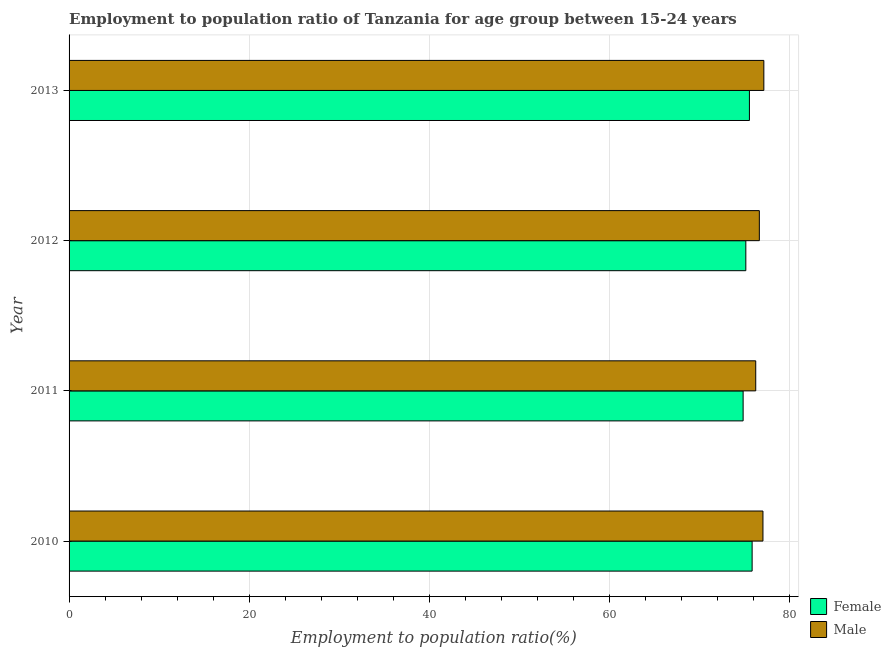Are the number of bars per tick equal to the number of legend labels?
Ensure brevity in your answer.  Yes. Are the number of bars on each tick of the Y-axis equal?
Provide a succinct answer. Yes. What is the label of the 3rd group of bars from the top?
Keep it short and to the point. 2011. In how many cases, is the number of bars for a given year not equal to the number of legend labels?
Provide a short and direct response. 0. What is the employment to population ratio(female) in 2012?
Offer a terse response. 75.1. Across all years, what is the maximum employment to population ratio(female)?
Ensure brevity in your answer.  75.8. Across all years, what is the minimum employment to population ratio(male)?
Your answer should be very brief. 76.2. In which year was the employment to population ratio(female) maximum?
Keep it short and to the point. 2010. In which year was the employment to population ratio(male) minimum?
Provide a succinct answer. 2011. What is the total employment to population ratio(male) in the graph?
Offer a terse response. 306.9. What is the difference between the employment to population ratio(female) in 2010 and the employment to population ratio(male) in 2013?
Your response must be concise. -1.3. What is the average employment to population ratio(male) per year?
Provide a succinct answer. 76.72. In how many years, is the employment to population ratio(female) greater than 76 %?
Give a very brief answer. 0. Is the difference between the employment to population ratio(female) in 2012 and 2013 greater than the difference between the employment to population ratio(male) in 2012 and 2013?
Your response must be concise. Yes. What is the difference between the highest and the second highest employment to population ratio(female)?
Offer a very short reply. 0.3. In how many years, is the employment to population ratio(female) greater than the average employment to population ratio(female) taken over all years?
Ensure brevity in your answer.  2. How many bars are there?
Your answer should be compact. 8. Are the values on the major ticks of X-axis written in scientific E-notation?
Provide a succinct answer. No. How are the legend labels stacked?
Offer a very short reply. Vertical. What is the title of the graph?
Give a very brief answer. Employment to population ratio of Tanzania for age group between 15-24 years. Does "Fixed telephone" appear as one of the legend labels in the graph?
Ensure brevity in your answer.  No. What is the label or title of the X-axis?
Ensure brevity in your answer.  Employment to population ratio(%). What is the label or title of the Y-axis?
Keep it short and to the point. Year. What is the Employment to population ratio(%) of Female in 2010?
Give a very brief answer. 75.8. What is the Employment to population ratio(%) of Female in 2011?
Offer a terse response. 74.8. What is the Employment to population ratio(%) of Male in 2011?
Your answer should be compact. 76.2. What is the Employment to population ratio(%) of Female in 2012?
Make the answer very short. 75.1. What is the Employment to population ratio(%) in Male in 2012?
Give a very brief answer. 76.6. What is the Employment to population ratio(%) of Female in 2013?
Offer a terse response. 75.5. What is the Employment to population ratio(%) of Male in 2013?
Your answer should be very brief. 77.1. Across all years, what is the maximum Employment to population ratio(%) in Female?
Offer a very short reply. 75.8. Across all years, what is the maximum Employment to population ratio(%) in Male?
Provide a succinct answer. 77.1. Across all years, what is the minimum Employment to population ratio(%) of Female?
Provide a short and direct response. 74.8. Across all years, what is the minimum Employment to population ratio(%) of Male?
Your answer should be compact. 76.2. What is the total Employment to population ratio(%) in Female in the graph?
Give a very brief answer. 301.2. What is the total Employment to population ratio(%) of Male in the graph?
Offer a very short reply. 306.9. What is the difference between the Employment to population ratio(%) in Male in 2010 and that in 2012?
Give a very brief answer. 0.4. What is the difference between the Employment to population ratio(%) in Female in 2010 and that in 2013?
Keep it short and to the point. 0.3. What is the difference between the Employment to population ratio(%) in Male in 2010 and that in 2013?
Offer a terse response. -0.1. What is the difference between the Employment to population ratio(%) of Female in 2011 and that in 2012?
Give a very brief answer. -0.3. What is the difference between the Employment to population ratio(%) in Male in 2011 and that in 2012?
Ensure brevity in your answer.  -0.4. What is the difference between the Employment to population ratio(%) of Female in 2011 and that in 2013?
Your answer should be compact. -0.7. What is the difference between the Employment to population ratio(%) of Male in 2011 and that in 2013?
Make the answer very short. -0.9. What is the difference between the Employment to population ratio(%) of Female in 2010 and the Employment to population ratio(%) of Male in 2011?
Offer a terse response. -0.4. What is the difference between the Employment to population ratio(%) of Female in 2010 and the Employment to population ratio(%) of Male in 2013?
Offer a very short reply. -1.3. What is the difference between the Employment to population ratio(%) in Female in 2012 and the Employment to population ratio(%) in Male in 2013?
Keep it short and to the point. -2. What is the average Employment to population ratio(%) of Female per year?
Offer a very short reply. 75.3. What is the average Employment to population ratio(%) in Male per year?
Your answer should be very brief. 76.72. In the year 2011, what is the difference between the Employment to population ratio(%) in Female and Employment to population ratio(%) in Male?
Your response must be concise. -1.4. What is the ratio of the Employment to population ratio(%) of Female in 2010 to that in 2011?
Your answer should be compact. 1.01. What is the ratio of the Employment to population ratio(%) in Male in 2010 to that in 2011?
Give a very brief answer. 1.01. What is the ratio of the Employment to population ratio(%) in Female in 2010 to that in 2012?
Your answer should be compact. 1.01. What is the ratio of the Employment to population ratio(%) in Male in 2010 to that in 2012?
Your response must be concise. 1.01. What is the ratio of the Employment to population ratio(%) of Female in 2010 to that in 2013?
Your answer should be compact. 1. What is the ratio of the Employment to population ratio(%) in Male in 2010 to that in 2013?
Provide a short and direct response. 1. What is the ratio of the Employment to population ratio(%) of Female in 2011 to that in 2012?
Provide a short and direct response. 1. What is the ratio of the Employment to population ratio(%) in Male in 2011 to that in 2013?
Your answer should be very brief. 0.99. What is the ratio of the Employment to population ratio(%) of Female in 2012 to that in 2013?
Ensure brevity in your answer.  0.99. What is the ratio of the Employment to population ratio(%) of Male in 2012 to that in 2013?
Provide a short and direct response. 0.99. What is the difference between the highest and the lowest Employment to population ratio(%) of Female?
Make the answer very short. 1. 